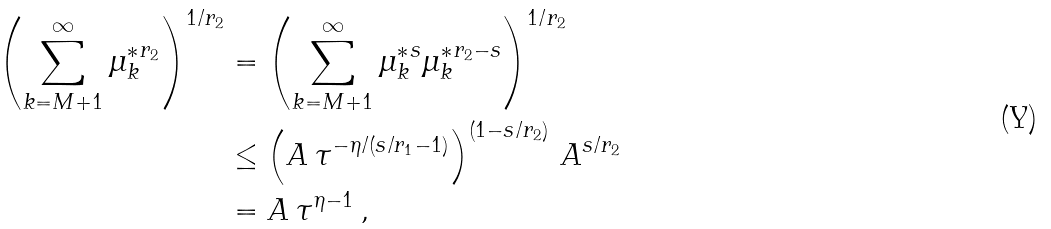Convert formula to latex. <formula><loc_0><loc_0><loc_500><loc_500>\left ( \sum _ { k = M + 1 } ^ { \infty } { \mu _ { k } ^ { * } } ^ { r _ { 2 } } \right ) ^ { 1 / r _ { 2 } } & = \left ( \sum _ { k = M + 1 } ^ { \infty } { \mu _ { k } ^ { * } } ^ { s } { \mu _ { k } ^ { * } } ^ { r _ { 2 } - s } \right ) ^ { 1 / r _ { 2 } } \, \\ & \leq \left ( A \, \tau ^ { - \eta / ( s / r _ { 1 } - 1 ) } \right ) ^ { ( 1 - s / r _ { 2 } ) } \, A ^ { s / r _ { 2 } } \\ & = A \, \tau ^ { \eta - 1 } \, ,</formula> 